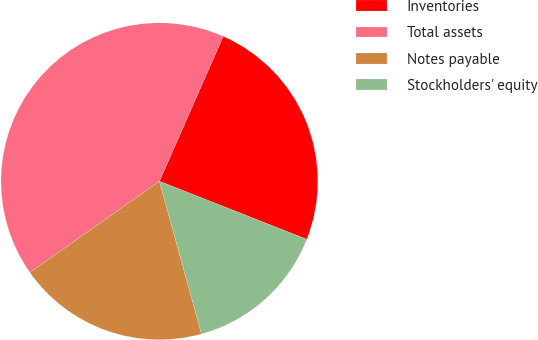Convert chart. <chart><loc_0><loc_0><loc_500><loc_500><pie_chart><fcel>Inventories<fcel>Total assets<fcel>Notes payable<fcel>Stockholders' equity<nl><fcel>24.37%<fcel>41.37%<fcel>19.51%<fcel>14.75%<nl></chart> 